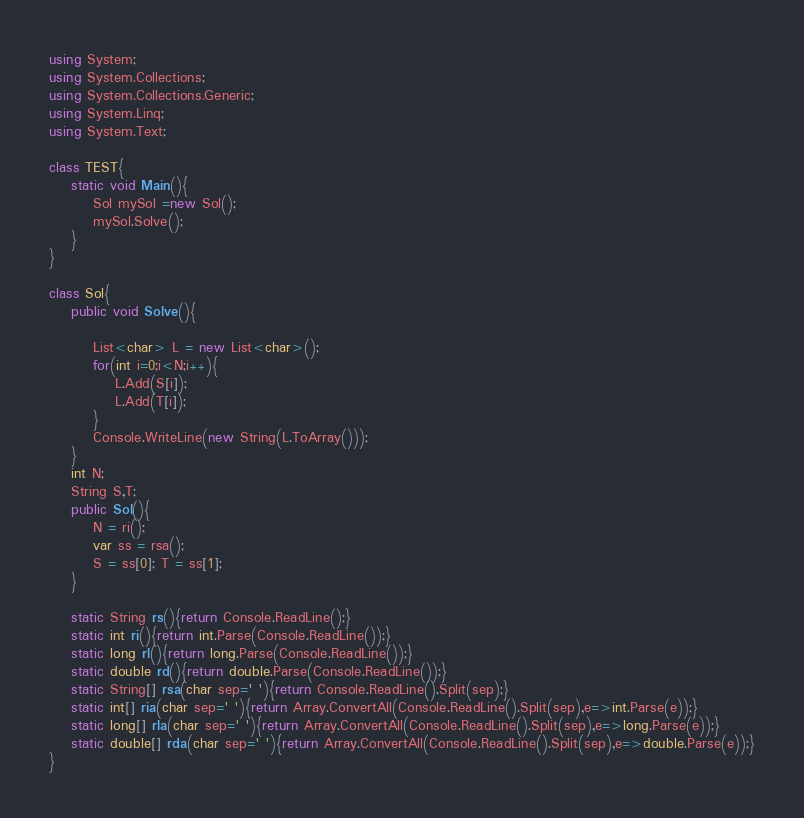<code> <loc_0><loc_0><loc_500><loc_500><_C#_>using System;
using System.Collections;
using System.Collections.Generic;
using System.Linq;
using System.Text;

class TEST{
	static void Main(){
		Sol mySol =new Sol();
		mySol.Solve();
	}
}

class Sol{
	public void Solve(){
		
		List<char> L = new List<char>();
		for(int i=0;i<N;i++){
			L.Add(S[i]);
			L.Add(T[i]);
		}
		Console.WriteLine(new String(L.ToArray()));
	}
	int N;
	String S,T;
	public Sol(){
		N = ri();
		var ss = rsa();
		S = ss[0]; T = ss[1];
	}

	static String rs(){return Console.ReadLine();}
	static int ri(){return int.Parse(Console.ReadLine());}
	static long rl(){return long.Parse(Console.ReadLine());}
	static double rd(){return double.Parse(Console.ReadLine());}
	static String[] rsa(char sep=' '){return Console.ReadLine().Split(sep);}
	static int[] ria(char sep=' '){return Array.ConvertAll(Console.ReadLine().Split(sep),e=>int.Parse(e));}
	static long[] rla(char sep=' '){return Array.ConvertAll(Console.ReadLine().Split(sep),e=>long.Parse(e));}
	static double[] rda(char sep=' '){return Array.ConvertAll(Console.ReadLine().Split(sep),e=>double.Parse(e));}
}
</code> 